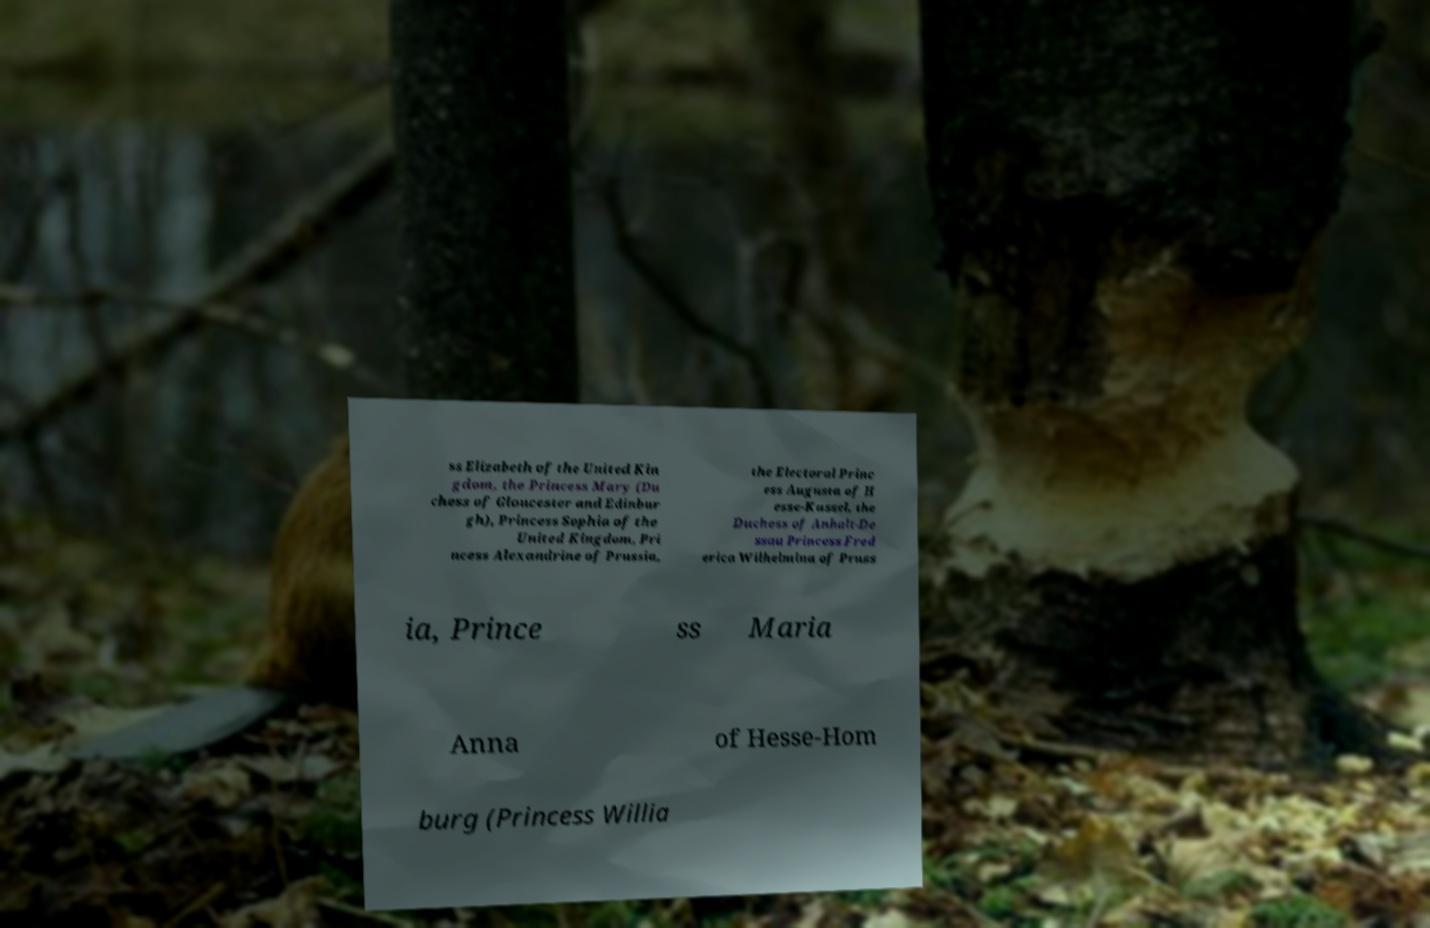For documentation purposes, I need the text within this image transcribed. Could you provide that? ss Elizabeth of the United Kin gdom, the Princess Mary (Du chess of Gloucester and Edinbur gh), Princess Sophia of the United Kingdom, Pri ncess Alexandrine of Prussia, the Electoral Princ ess Augusta of H esse-Kassel, the Duchess of Anhalt-De ssau Princess Fred erica Wilhelmina of Pruss ia, Prince ss Maria Anna of Hesse-Hom burg (Princess Willia 